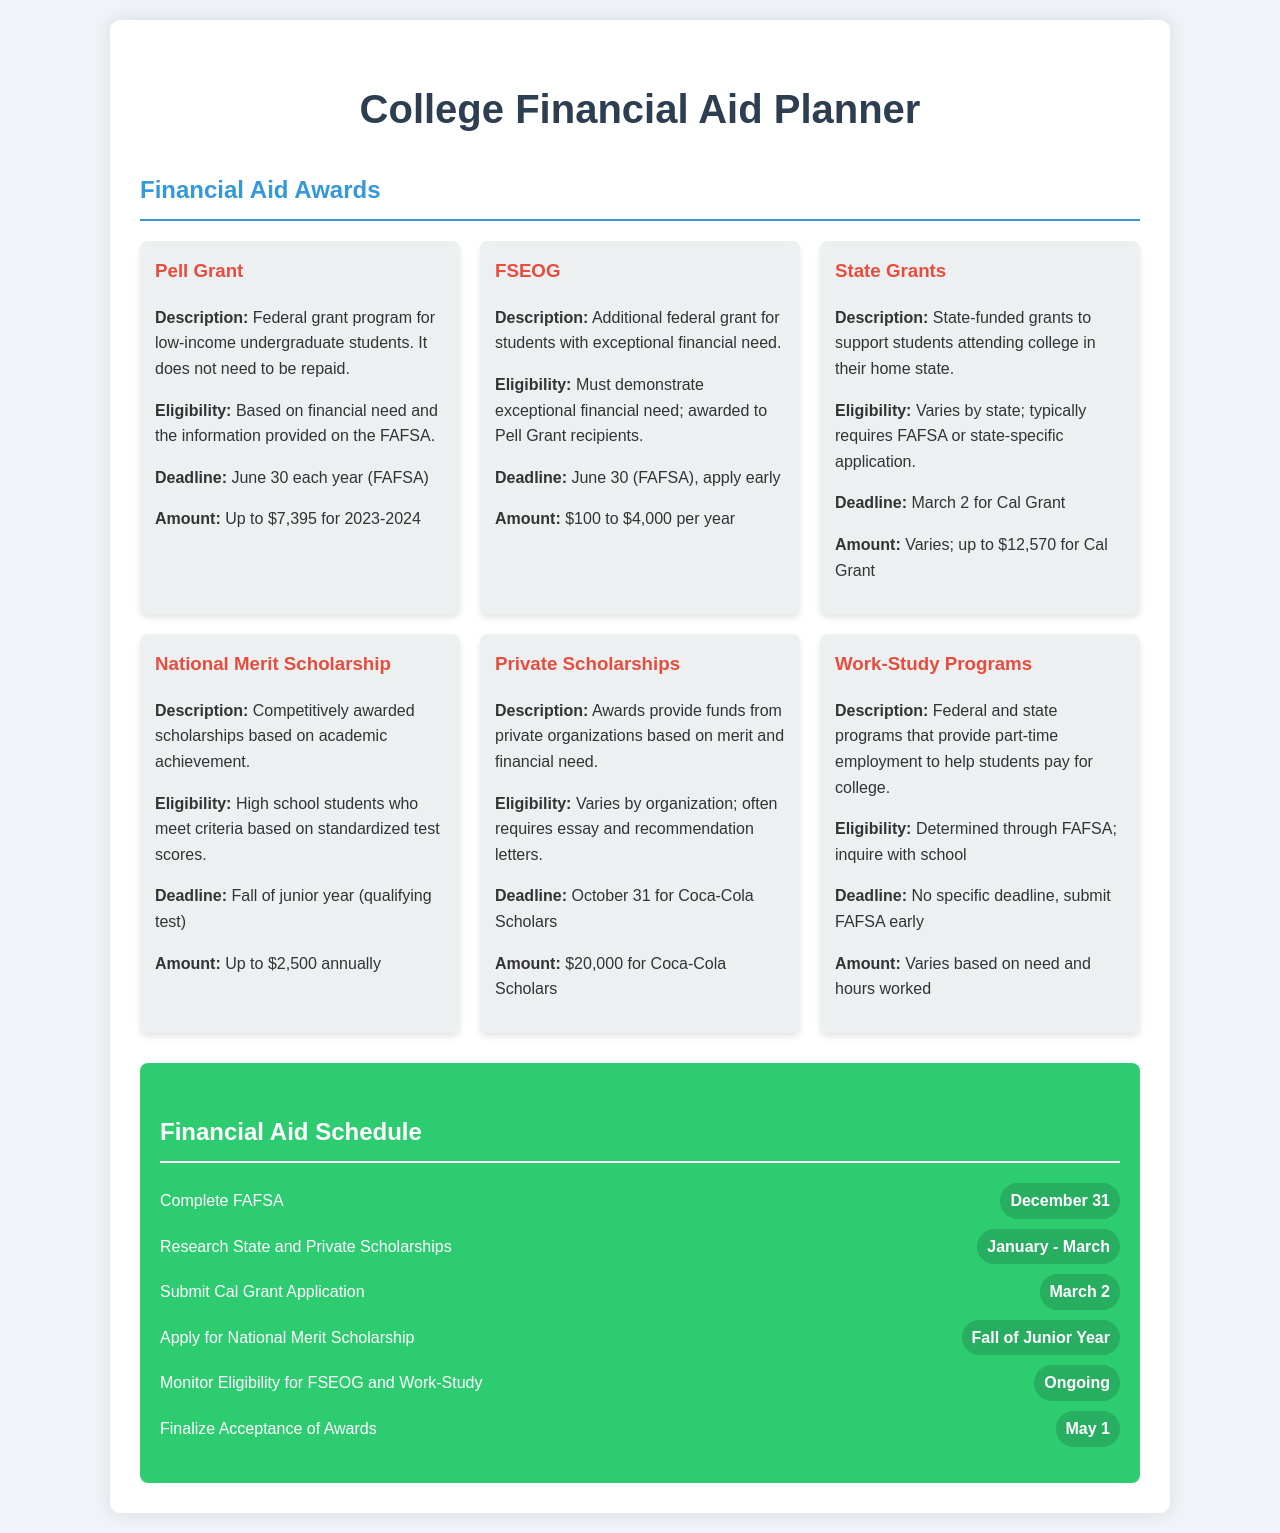What is the maximum amount for a Pell Grant? The maximum amount for a Pell Grant for the 2023-2024 year is stated in the document.
Answer: Up to $7,395 What is the deadline to submit the Cal Grant Application? The document specifies the deadline for the Cal Grant Application.
Answer: March 2 What type of financial aid requires the FAFSA for eligibility? The document mentions several types of financial aid, and this one is specifically associated with the FAFSA process.
Answer: FSEOG What is the amount for Coca-Cola Scholars? The document provides specific information about the amount awarded for Coca-Cola Scholars.
Answer: $20,000 When should the FAFSA be completed? The document provides a timeline for completing the FAFSA, which affects financial aid eligibility.
Answer: December 31 Which financial aid option has no specific deadline mentioned? A certain type of financial aid is highlighted in the document as having no specific deadline; this is related to employment opportunities.
Answer: Work-Study Programs What is the eligibility requirement for the National Merit Scholarship? The document outlines eligibility requirements for this particular scholarship, focusing on high school achievements.
Answer: High school students who meet criteria based on standardized test scores When is the final date to accept financial aid awards? The document states an important date related to the acceptance of financial aid offers.
Answer: May 1 What awards require applying early? The document highlights certain awards where early application is advised, emphasizing urgency and recommendation.
Answer: FSEOG 